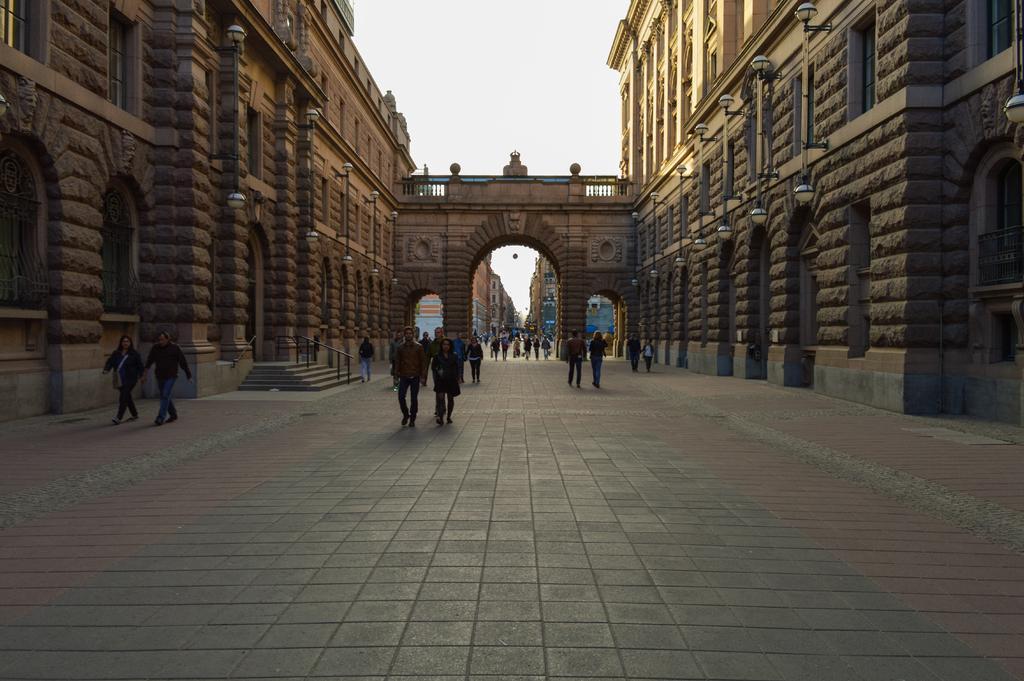Could you give a brief overview of what you see in this image? In this image in the center there are a group of people who are walking, and on the right side and left side there are buildings. And in the background there is a wall, railing and buildings. At the top there is sky, and at the bottom there is a walkway. 